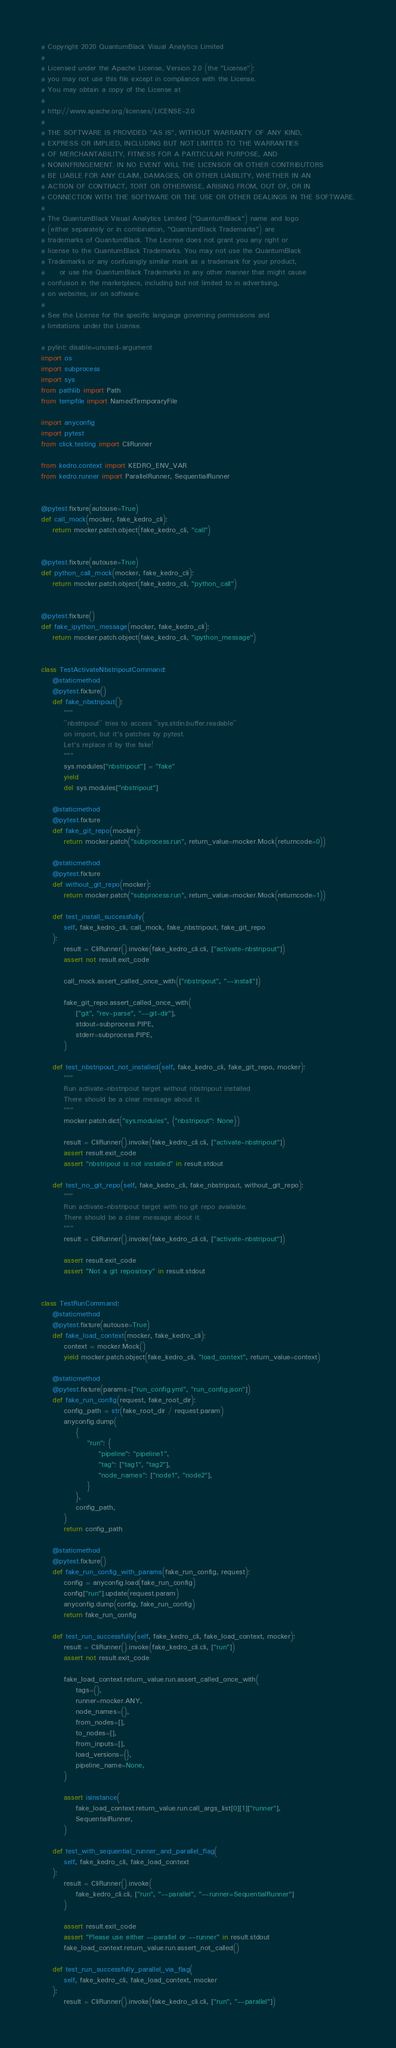Convert code to text. <code><loc_0><loc_0><loc_500><loc_500><_Python_># Copyright 2020 QuantumBlack Visual Analytics Limited
#
# Licensed under the Apache License, Version 2.0 (the "License");
# you may not use this file except in compliance with the License.
# You may obtain a copy of the License at
#
# http://www.apache.org/licenses/LICENSE-2.0
#
# THE SOFTWARE IS PROVIDED "AS IS", WITHOUT WARRANTY OF ANY KIND,
# EXPRESS OR IMPLIED, INCLUDING BUT NOT LIMITED TO THE WARRANTIES
# OF MERCHANTABILITY, FITNESS FOR A PARTICULAR PURPOSE, AND
# NONINFRINGEMENT. IN NO EVENT WILL THE LICENSOR OR OTHER CONTRIBUTORS
# BE LIABLE FOR ANY CLAIM, DAMAGES, OR OTHER LIABILITY, WHETHER IN AN
# ACTION OF CONTRACT, TORT OR OTHERWISE, ARISING FROM, OUT OF, OR IN
# CONNECTION WITH THE SOFTWARE OR THE USE OR OTHER DEALINGS IN THE SOFTWARE.
#
# The QuantumBlack Visual Analytics Limited ("QuantumBlack") name and logo
# (either separately or in combination, "QuantumBlack Trademarks") are
# trademarks of QuantumBlack. The License does not grant you any right or
# license to the QuantumBlack Trademarks. You may not use the QuantumBlack
# Trademarks or any confusingly similar mark as a trademark for your product,
#     or use the QuantumBlack Trademarks in any other manner that might cause
# confusion in the marketplace, including but not limited to in advertising,
# on websites, or on software.
#
# See the License for the specific language governing permissions and
# limitations under the License.

# pylint: disable=unused-argument
import os
import subprocess
import sys
from pathlib import Path
from tempfile import NamedTemporaryFile

import anyconfig
import pytest
from click.testing import CliRunner

from kedro.context import KEDRO_ENV_VAR
from kedro.runner import ParallelRunner, SequentialRunner


@pytest.fixture(autouse=True)
def call_mock(mocker, fake_kedro_cli):
    return mocker.patch.object(fake_kedro_cli, "call")


@pytest.fixture(autouse=True)
def python_call_mock(mocker, fake_kedro_cli):
    return mocker.patch.object(fake_kedro_cli, "python_call")


@pytest.fixture()
def fake_ipython_message(mocker, fake_kedro_cli):
    return mocker.patch.object(fake_kedro_cli, "ipython_message")


class TestActivateNbstripoutCommand:
    @staticmethod
    @pytest.fixture()
    def fake_nbstripout():
        """
        ``nbstripout`` tries to access ``sys.stdin.buffer.readable``
        on import, but it's patches by pytest.
        Let's replace it by the fake!
        """
        sys.modules["nbstripout"] = "fake"
        yield
        del sys.modules["nbstripout"]

    @staticmethod
    @pytest.fixture
    def fake_git_repo(mocker):
        return mocker.patch("subprocess.run", return_value=mocker.Mock(returncode=0))

    @staticmethod
    @pytest.fixture
    def without_git_repo(mocker):
        return mocker.patch("subprocess.run", return_value=mocker.Mock(returncode=1))

    def test_install_successfully(
        self, fake_kedro_cli, call_mock, fake_nbstripout, fake_git_repo
    ):
        result = CliRunner().invoke(fake_kedro_cli.cli, ["activate-nbstripout"])
        assert not result.exit_code

        call_mock.assert_called_once_with(["nbstripout", "--install"])

        fake_git_repo.assert_called_once_with(
            ["git", "rev-parse", "--git-dir"],
            stdout=subprocess.PIPE,
            stderr=subprocess.PIPE,
        )

    def test_nbstripout_not_installed(self, fake_kedro_cli, fake_git_repo, mocker):
        """
        Run activate-nbstripout target without nbstripout installed
        There should be a clear message about it.
        """
        mocker.patch.dict("sys.modules", {"nbstripout": None})

        result = CliRunner().invoke(fake_kedro_cli.cli, ["activate-nbstripout"])
        assert result.exit_code
        assert "nbstripout is not installed" in result.stdout

    def test_no_git_repo(self, fake_kedro_cli, fake_nbstripout, without_git_repo):
        """
        Run activate-nbstripout target with no git repo available.
        There should be a clear message about it.
        """
        result = CliRunner().invoke(fake_kedro_cli.cli, ["activate-nbstripout"])

        assert result.exit_code
        assert "Not a git repository" in result.stdout


class TestRunCommand:
    @staticmethod
    @pytest.fixture(autouse=True)
    def fake_load_context(mocker, fake_kedro_cli):
        context = mocker.Mock()
        yield mocker.patch.object(fake_kedro_cli, "load_context", return_value=context)

    @staticmethod
    @pytest.fixture(params=["run_config.yml", "run_config.json"])
    def fake_run_config(request, fake_root_dir):
        config_path = str(fake_root_dir / request.param)
        anyconfig.dump(
            {
                "run": {
                    "pipeline": "pipeline1",
                    "tag": ["tag1", "tag2"],
                    "node_names": ["node1", "node2"],
                }
            },
            config_path,
        )
        return config_path

    @staticmethod
    @pytest.fixture()
    def fake_run_config_with_params(fake_run_config, request):
        config = anyconfig.load(fake_run_config)
        config["run"].update(request.param)
        anyconfig.dump(config, fake_run_config)
        return fake_run_config

    def test_run_successfully(self, fake_kedro_cli, fake_load_context, mocker):
        result = CliRunner().invoke(fake_kedro_cli.cli, ["run"])
        assert not result.exit_code

        fake_load_context.return_value.run.assert_called_once_with(
            tags=(),
            runner=mocker.ANY,
            node_names=(),
            from_nodes=[],
            to_nodes=[],
            from_inputs=[],
            load_versions={},
            pipeline_name=None,
        )

        assert isinstance(
            fake_load_context.return_value.run.call_args_list[0][1]["runner"],
            SequentialRunner,
        )

    def test_with_sequential_runner_and_parallel_flag(
        self, fake_kedro_cli, fake_load_context
    ):
        result = CliRunner().invoke(
            fake_kedro_cli.cli, ["run", "--parallel", "--runner=SequentialRunner"]
        )

        assert result.exit_code
        assert "Please use either --parallel or --runner" in result.stdout
        fake_load_context.return_value.run.assert_not_called()

    def test_run_successfully_parallel_via_flag(
        self, fake_kedro_cli, fake_load_context, mocker
    ):
        result = CliRunner().invoke(fake_kedro_cli.cli, ["run", "--parallel"])
</code> 